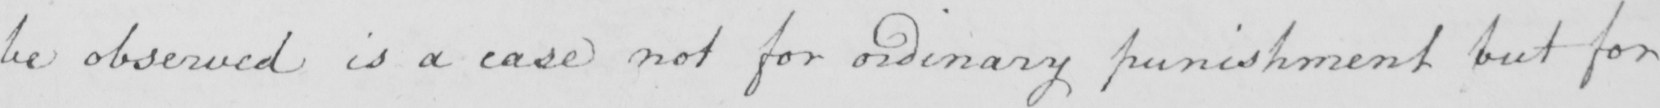What is written in this line of handwriting? be observed is a case not for ordinary punishment but for 